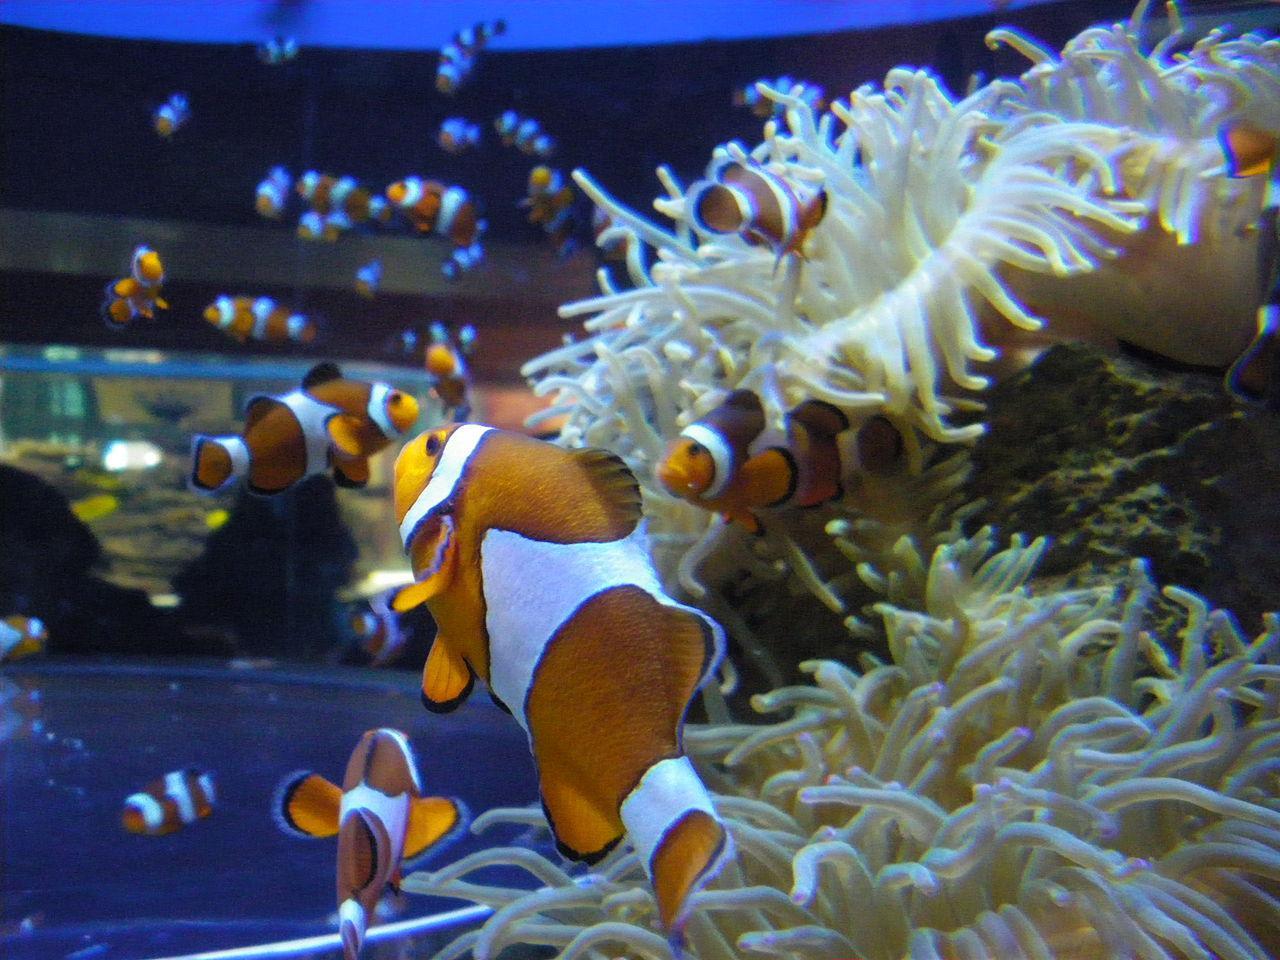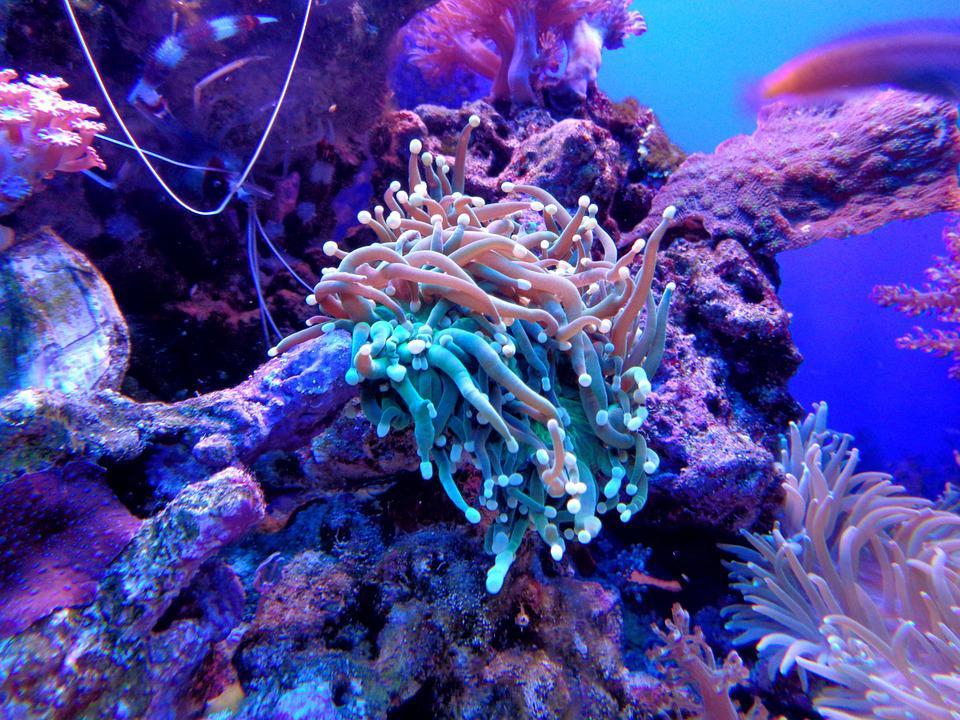The first image is the image on the left, the second image is the image on the right. Given the left and right images, does the statement "The left image shows one starfish swimming above anemone tendrils, and the right image includes a red-orange anemone." hold true? Answer yes or no. No. The first image is the image on the left, the second image is the image on the right. For the images displayed, is the sentence "There are orange, black and white stripe section on a single cloud fish that is in the arms of the corral." factually correct? Answer yes or no. No. 